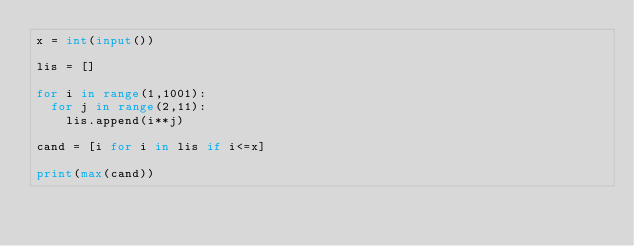Convert code to text. <code><loc_0><loc_0><loc_500><loc_500><_Python_>x = int(input())

lis = []

for i in range(1,1001):
	for j in range(2,11):
		lis.append(i**j)

cand = [i for i in lis if i<=x]

print(max(cand))</code> 